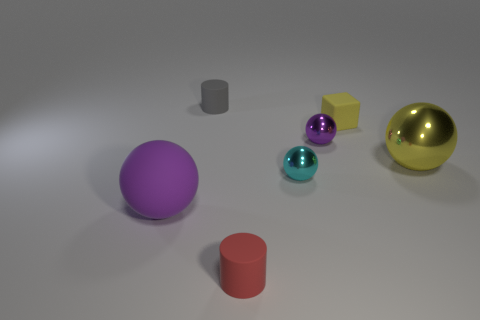What is the object that is both behind the red rubber cylinder and in front of the cyan ball made of?
Ensure brevity in your answer.  Rubber. What is the color of the tiny thing that is both behind the red matte cylinder and left of the cyan ball?
Give a very brief answer. Gray. Is there anything else that is the same color as the small block?
Ensure brevity in your answer.  Yes. The purple thing on the right side of the big thing that is on the left side of the purple ball that is behind the small cyan sphere is what shape?
Offer a terse response. Sphere. What is the color of the large shiny object that is the same shape as the tiny cyan object?
Give a very brief answer. Yellow. The rubber cylinder right of the cylinder behind the purple metallic sphere is what color?
Keep it short and to the point. Red. The other matte object that is the same shape as the tiny red object is what size?
Your response must be concise. Small. How many tiny blue balls are made of the same material as the cube?
Your answer should be compact. 0. How many purple spheres are left of the purple shiny sphere to the left of the yellow ball?
Your answer should be very brief. 1. Are there any yellow things to the left of the red object?
Your answer should be very brief. No. 